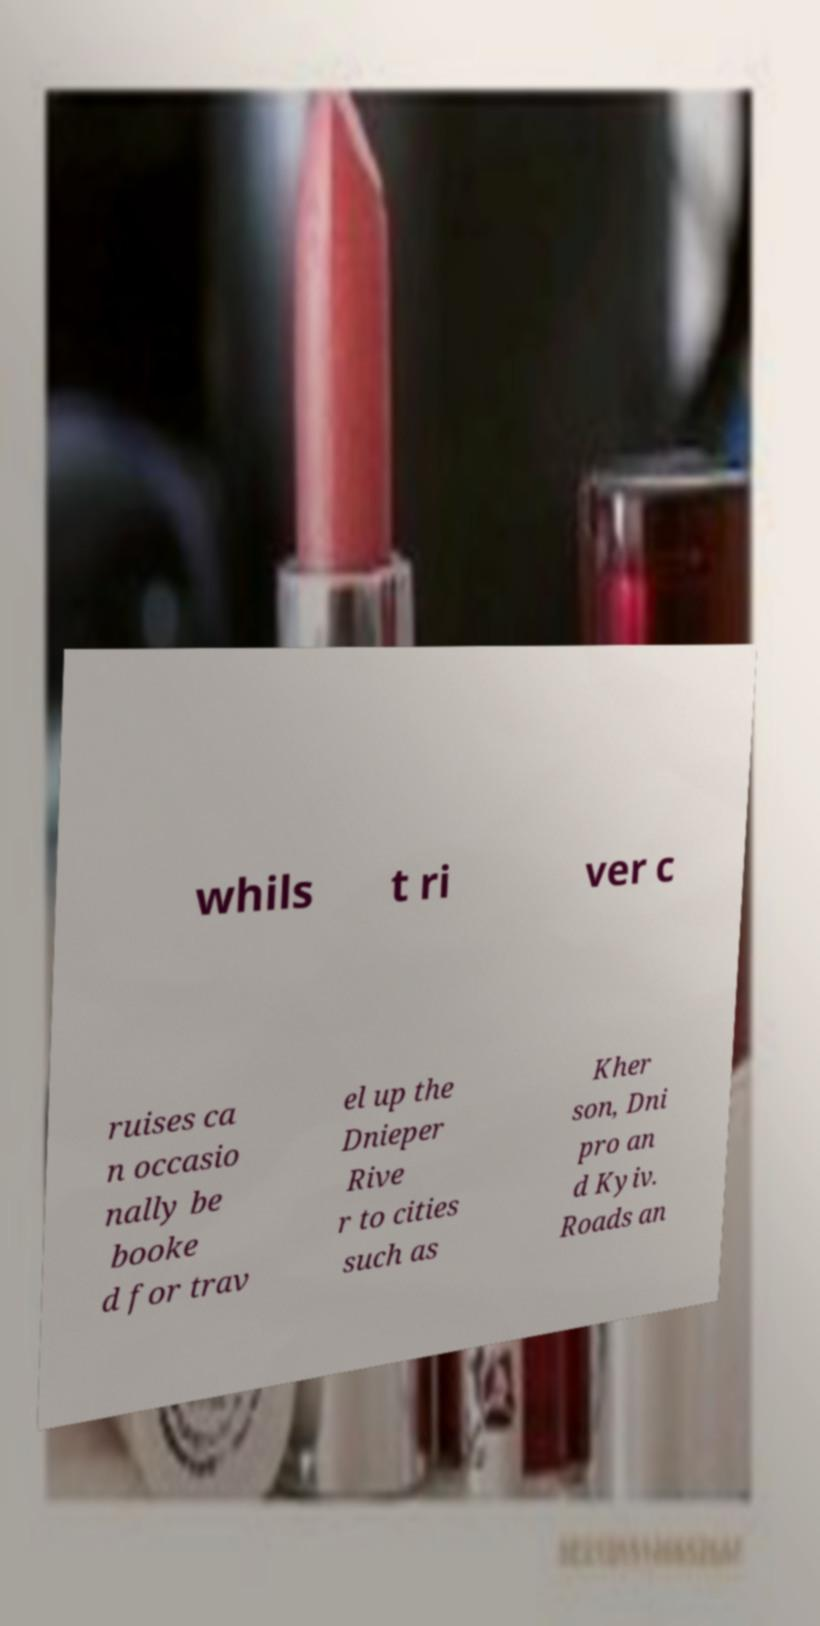I need the written content from this picture converted into text. Can you do that? whils t ri ver c ruises ca n occasio nally be booke d for trav el up the Dnieper Rive r to cities such as Kher son, Dni pro an d Kyiv. Roads an 